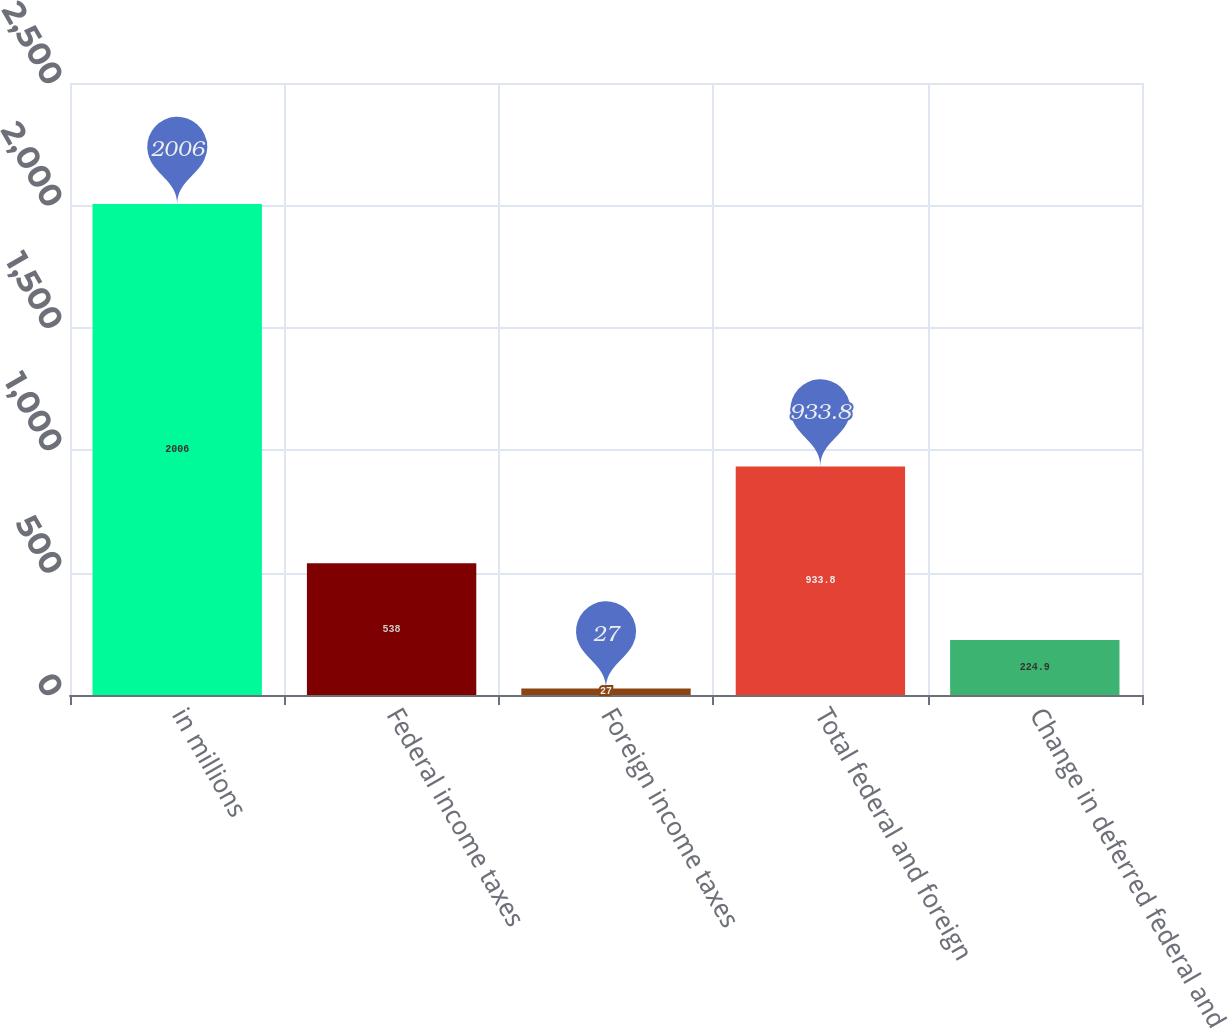<chart> <loc_0><loc_0><loc_500><loc_500><bar_chart><fcel>in millions<fcel>Federal income taxes<fcel>Foreign income taxes<fcel>Total federal and foreign<fcel>Change in deferred federal and<nl><fcel>2006<fcel>538<fcel>27<fcel>933.8<fcel>224.9<nl></chart> 